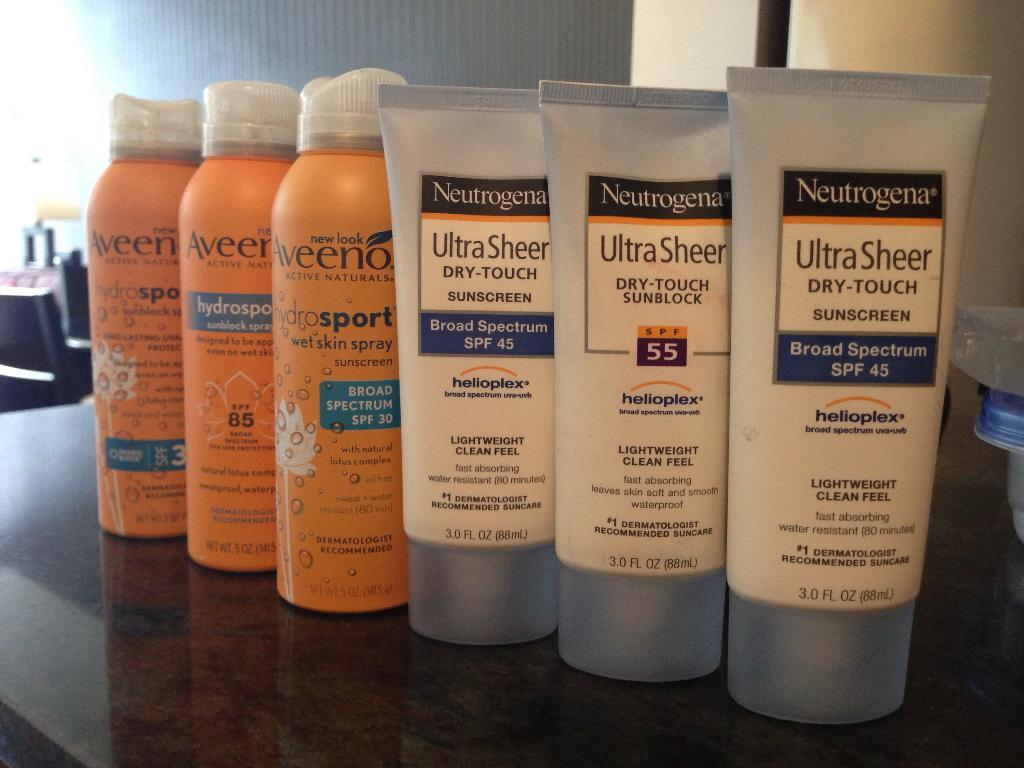How many cream tubes are in the image? There are three cream tubes in the image. How many spray bottles are in the image? There are three spray bottles in the image. Where are the cream tubes and spray bottles located? The cream tubes and spray bottles are on a table. What can be seen in the background of the image? There are objects visible in the background of the image, including a wall. What type of thread is being used to connect the cream tubes and spray bottles in the image? There is no thread connecting the cream tubes and spray bottles in the image. What part of the wall is being illuminated by a bulb in the image? There is no bulb present in the image, so it is not possible to determine which part of the wall is being illuminated. 